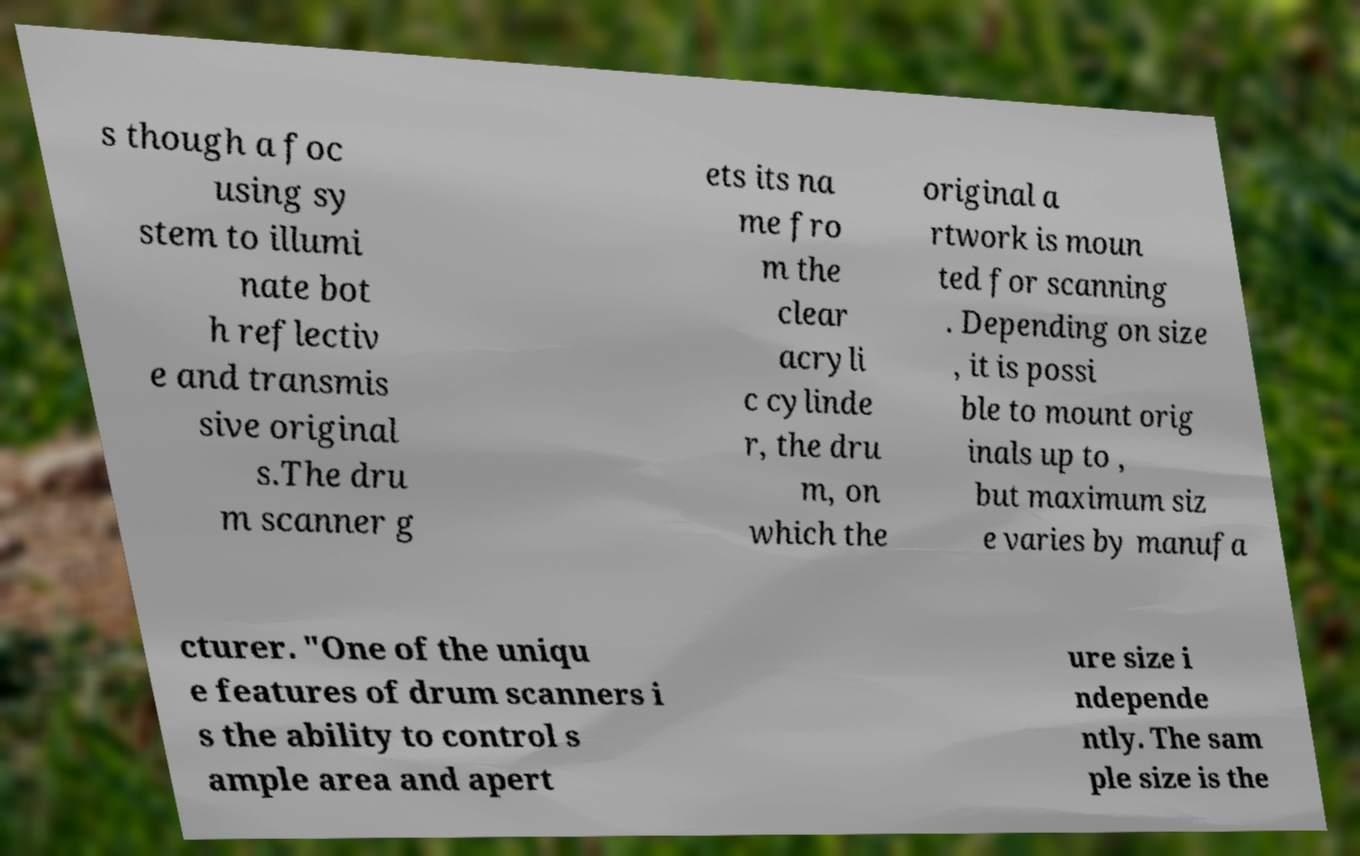What messages or text are displayed in this image? I need them in a readable, typed format. s though a foc using sy stem to illumi nate bot h reflectiv e and transmis sive original s.The dru m scanner g ets its na me fro m the clear acryli c cylinde r, the dru m, on which the original a rtwork is moun ted for scanning . Depending on size , it is possi ble to mount orig inals up to , but maximum siz e varies by manufa cturer. "One of the uniqu e features of drum scanners i s the ability to control s ample area and apert ure size i ndepende ntly. The sam ple size is the 